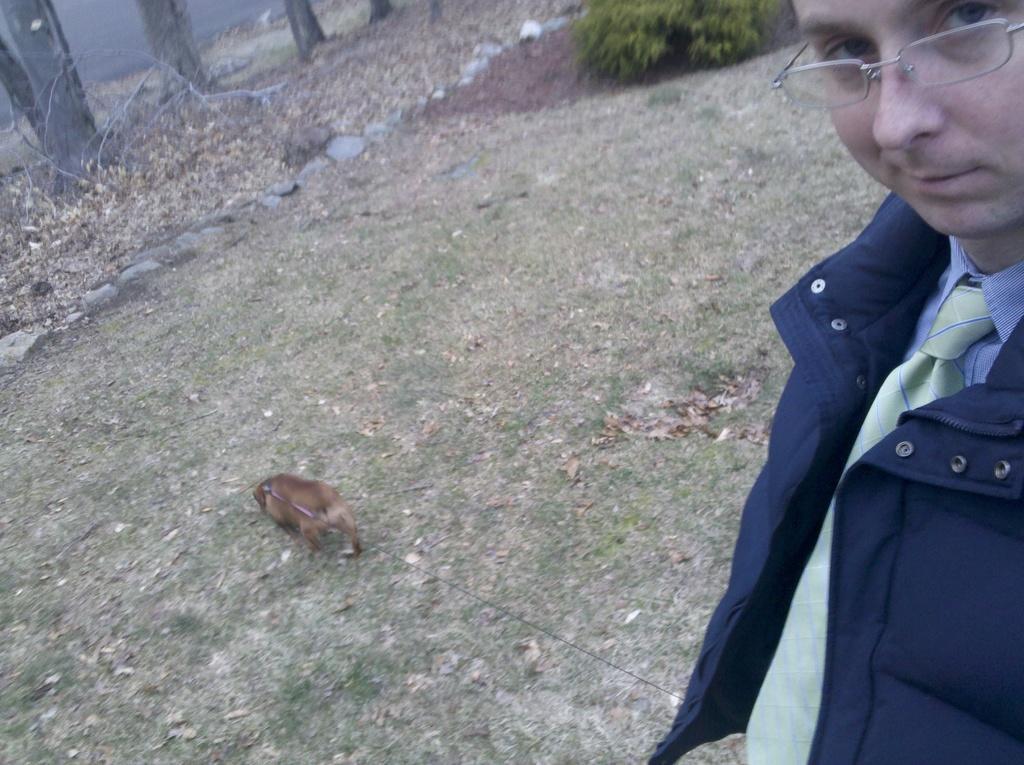Could you give a brief overview of what you see in this image? In the picture we can see a grass surface on it, we can see a man standing and holding a dog with belts and in the background, we can see stones, plants, tree branches with some dried twigs and leaves on the path. 